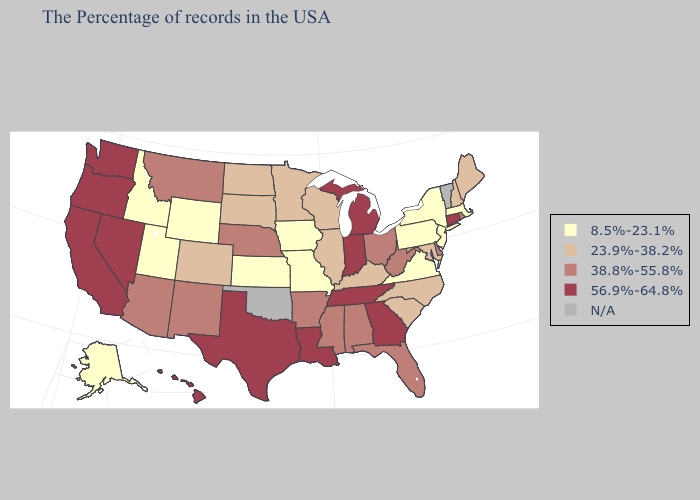What is the value of Maine?
Answer briefly. 23.9%-38.2%. Among the states that border Minnesota , does Wisconsin have the lowest value?
Give a very brief answer. No. Name the states that have a value in the range 38.8%-55.8%?
Answer briefly. Rhode Island, Delaware, West Virginia, Ohio, Florida, Alabama, Mississippi, Arkansas, Nebraska, New Mexico, Montana, Arizona. What is the highest value in states that border Arizona?
Answer briefly. 56.9%-64.8%. What is the value of Minnesota?
Short answer required. 23.9%-38.2%. What is the value of Mississippi?
Keep it brief. 38.8%-55.8%. What is the highest value in states that border Massachusetts?
Answer briefly. 56.9%-64.8%. Which states have the highest value in the USA?
Quick response, please. Connecticut, Georgia, Michigan, Indiana, Tennessee, Louisiana, Texas, Nevada, California, Washington, Oregon, Hawaii. Among the states that border Colorado , which have the lowest value?
Answer briefly. Kansas, Wyoming, Utah. What is the lowest value in the USA?
Short answer required. 8.5%-23.1%. Which states hav the highest value in the South?
Keep it brief. Georgia, Tennessee, Louisiana, Texas. What is the highest value in the West ?
Write a very short answer. 56.9%-64.8%. Name the states that have a value in the range 38.8%-55.8%?
Short answer required. Rhode Island, Delaware, West Virginia, Ohio, Florida, Alabama, Mississippi, Arkansas, Nebraska, New Mexico, Montana, Arizona. Name the states that have a value in the range 38.8%-55.8%?
Be succinct. Rhode Island, Delaware, West Virginia, Ohio, Florida, Alabama, Mississippi, Arkansas, Nebraska, New Mexico, Montana, Arizona. Name the states that have a value in the range 23.9%-38.2%?
Give a very brief answer. Maine, New Hampshire, Maryland, North Carolina, South Carolina, Kentucky, Wisconsin, Illinois, Minnesota, South Dakota, North Dakota, Colorado. 